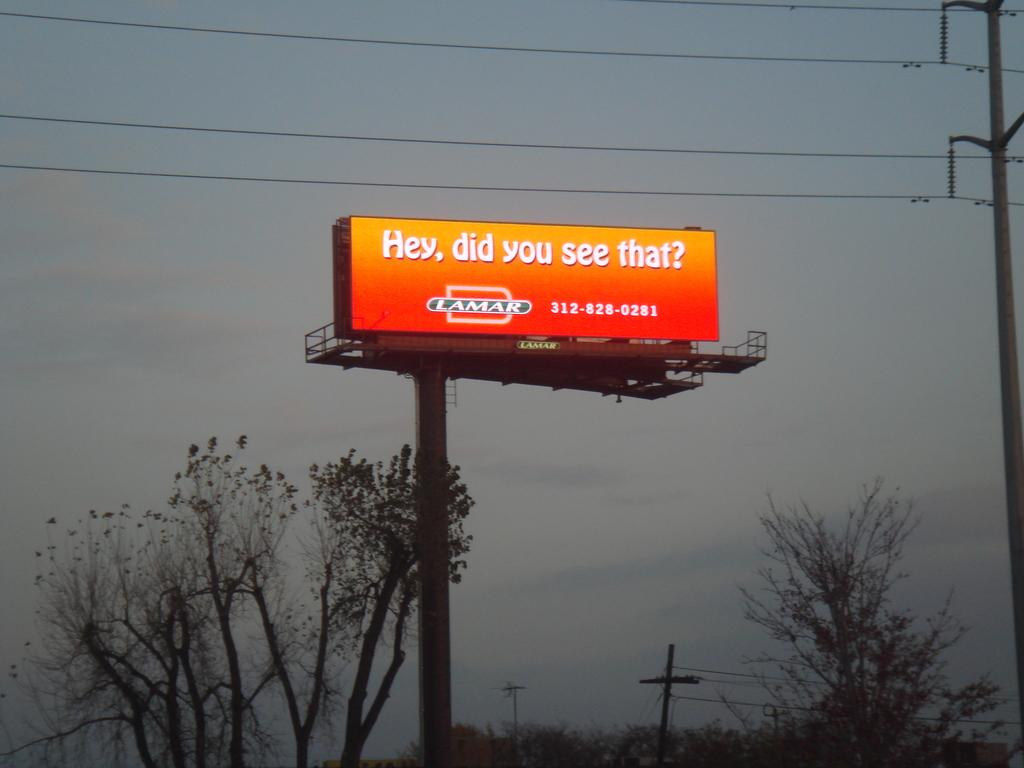<image>
Give a short and clear explanation of the subsequent image. A yellow and orange billboard asks Hey, did you see that?. 